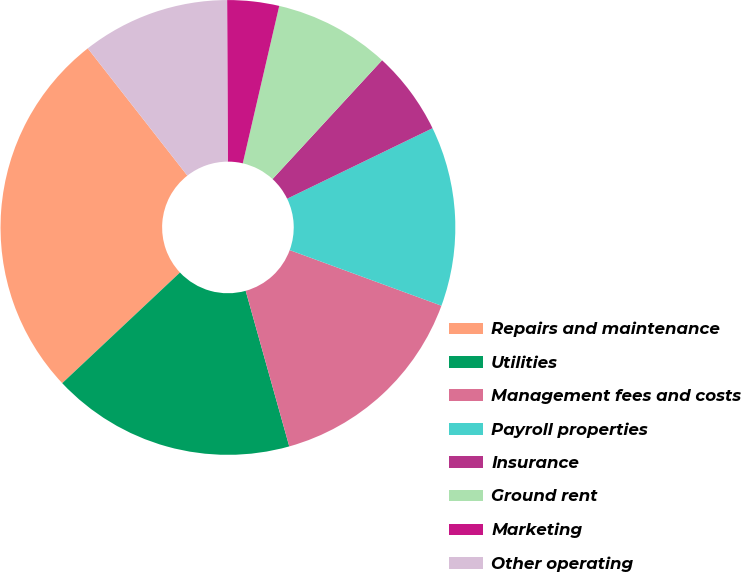Convert chart. <chart><loc_0><loc_0><loc_500><loc_500><pie_chart><fcel>Repairs and maintenance<fcel>Utilities<fcel>Management fees and costs<fcel>Payroll properties<fcel>Insurance<fcel>Ground rent<fcel>Marketing<fcel>Other operating<nl><fcel>26.44%<fcel>17.34%<fcel>15.06%<fcel>12.78%<fcel>5.96%<fcel>8.23%<fcel>3.68%<fcel>10.51%<nl></chart> 